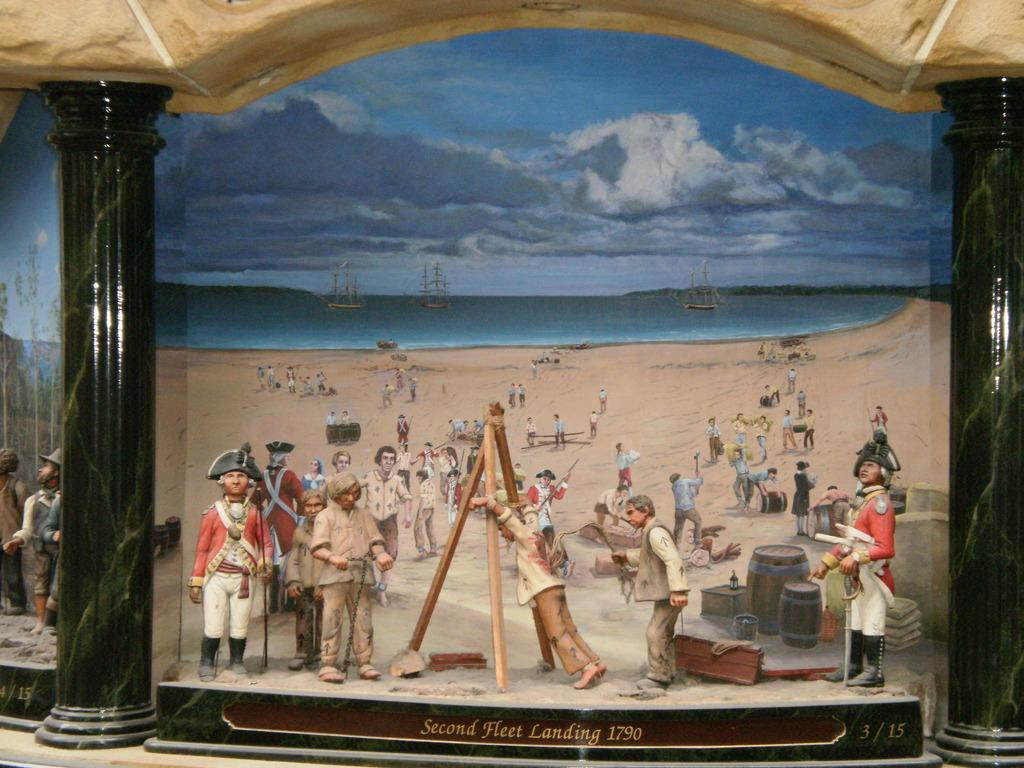<image>
Write a terse but informative summary of the picture. An art exhibit showing the second fleet landing in the year 1790. 